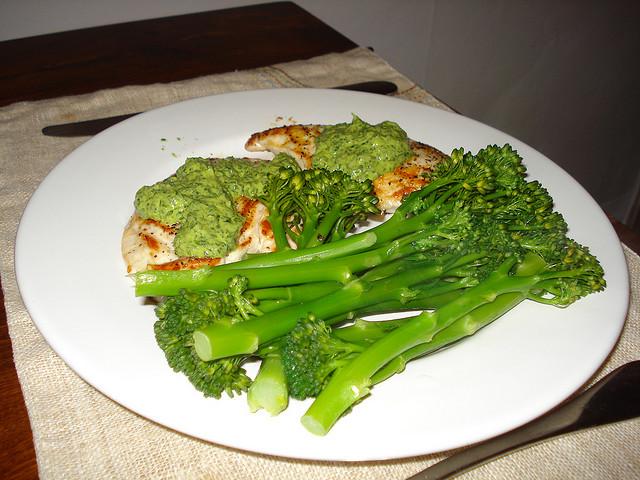What is the green stuff on the plate?
Concise answer only. Broccoli. Is this in a box?
Give a very brief answer. No. What is the main ingredient in this food dish?
Be succinct. Broccoli. What is the green stuff on the side of plate?
Quick response, please. Broccoli. What is the food in?
Write a very short answer. Plate. What is the green vegetable on the further plate?
Concise answer only. Broccoli. Does the plate have a band around the edge?
Quick response, please. No. What is the dark green vegetable?
Answer briefly. Broccoli. Is this a vegetarian meal?
Keep it brief. No. Are there any utensils on the plate?
Give a very brief answer. No. Which are green?
Short answer required. Broccoli. Is this a healthy meal?
Quick response, please. Yes. What type of food is closest to the edge of the plate at the bottom of the picture?
Answer briefly. Broccoli. Are there sesame seeds in this dish?
Answer briefly. No. Is the plate blue?
Short answer required. No. Is the broccoli cooked?
Answer briefly. Yes. Where is a butter knife?
Write a very short answer. Next to plate. What is the vegetable on?
Write a very short answer. Plate. What is this food inside of?
Quick response, please. Plate. What kind of vegetable is on the plate?
Keep it brief. Broccoli. What type of cuisine is this?
Quick response, please. Vegetarian. Is there chicken on this plate?
Answer briefly. Yes. What is the green stuff?
Be succinct. Broccoli. What color is the plate?
Answer briefly. White. What vegetable is shown on the right side?
Short answer required. Broccoli. What is the vegetable?
Answer briefly. Broccoli. Does the meal look delicious?
Short answer required. Yes. Have the vegetables been cooked?
Short answer required. Yes. What is the green food?
Write a very short answer. Broccoli. Is any silverware on the plate?
Keep it brief. No. 